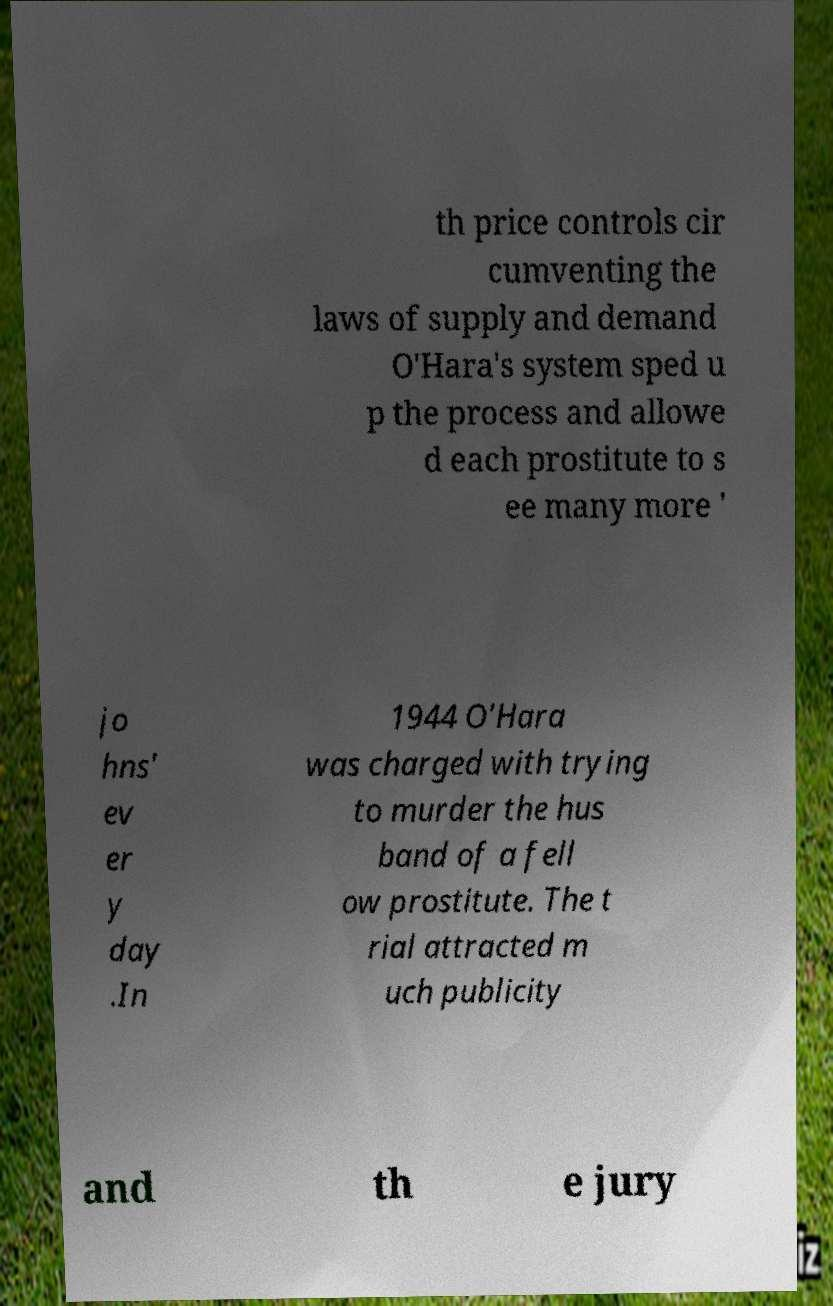Could you extract and type out the text from this image? th price controls cir cumventing the laws of supply and demand O'Hara's system sped u p the process and allowe d each prostitute to s ee many more ' jo hns' ev er y day .In 1944 O'Hara was charged with trying to murder the hus band of a fell ow prostitute. The t rial attracted m uch publicity and th e jury 